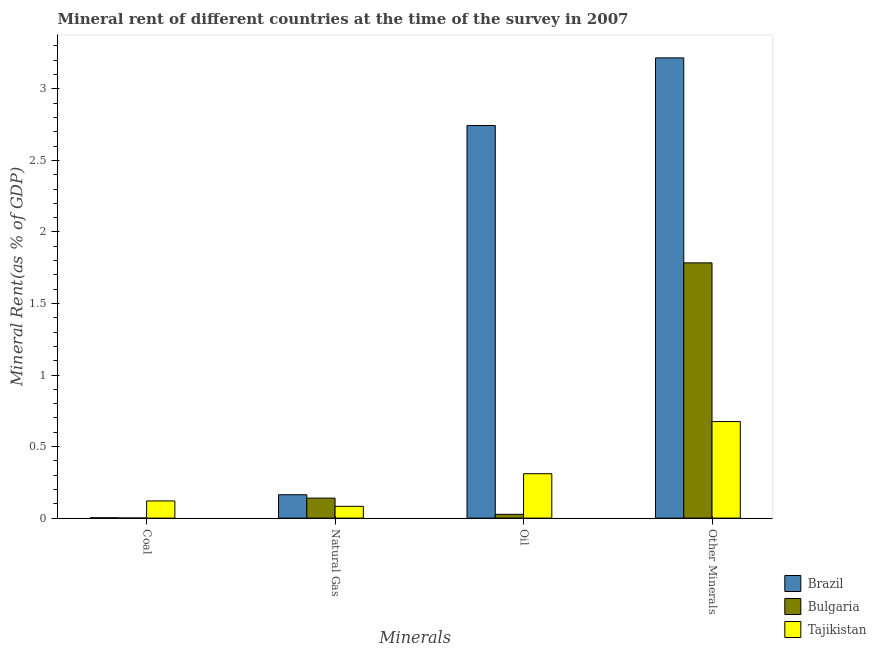How many different coloured bars are there?
Make the answer very short. 3. Are the number of bars per tick equal to the number of legend labels?
Your answer should be very brief. Yes. Are the number of bars on each tick of the X-axis equal?
Your answer should be compact. Yes. How many bars are there on the 1st tick from the left?
Provide a short and direct response. 3. How many bars are there on the 4th tick from the right?
Ensure brevity in your answer.  3. What is the label of the 3rd group of bars from the left?
Offer a terse response. Oil. What is the oil rent in Bulgaria?
Provide a short and direct response. 0.03. Across all countries, what is the maximum  rent of other minerals?
Ensure brevity in your answer.  3.22. Across all countries, what is the minimum oil rent?
Keep it short and to the point. 0.03. What is the total coal rent in the graph?
Make the answer very short. 0.12. What is the difference between the oil rent in Tajikistan and that in Bulgaria?
Provide a short and direct response. 0.28. What is the difference between the coal rent in Bulgaria and the  rent of other minerals in Brazil?
Provide a succinct answer. -3.22. What is the average  rent of other minerals per country?
Your answer should be very brief. 1.89. What is the difference between the natural gas rent and  rent of other minerals in Brazil?
Give a very brief answer. -3.05. In how many countries, is the oil rent greater than 0.1 %?
Provide a succinct answer. 2. What is the ratio of the natural gas rent in Tajikistan to that in Brazil?
Keep it short and to the point. 0.5. What is the difference between the highest and the second highest natural gas rent?
Give a very brief answer. 0.02. What is the difference between the highest and the lowest  rent of other minerals?
Provide a succinct answer. 2.54. In how many countries, is the natural gas rent greater than the average natural gas rent taken over all countries?
Give a very brief answer. 2. Is the sum of the natural gas rent in Bulgaria and Tajikistan greater than the maximum oil rent across all countries?
Provide a succinct answer. No. Is it the case that in every country, the sum of the oil rent and natural gas rent is greater than the sum of coal rent and  rent of other minerals?
Give a very brief answer. No. What does the 1st bar from the left in Oil represents?
Your response must be concise. Brazil. What does the 3rd bar from the right in Oil represents?
Ensure brevity in your answer.  Brazil. How many bars are there?
Your answer should be compact. 12. What is the difference between two consecutive major ticks on the Y-axis?
Give a very brief answer. 0.5. What is the title of the graph?
Offer a terse response. Mineral rent of different countries at the time of the survey in 2007. Does "Latvia" appear as one of the legend labels in the graph?
Give a very brief answer. No. What is the label or title of the X-axis?
Your answer should be very brief. Minerals. What is the label or title of the Y-axis?
Provide a short and direct response. Mineral Rent(as % of GDP). What is the Mineral Rent(as % of GDP) in Brazil in Coal?
Offer a very short reply. 0. What is the Mineral Rent(as % of GDP) of Bulgaria in Coal?
Keep it short and to the point. 0. What is the Mineral Rent(as % of GDP) in Tajikistan in Coal?
Offer a terse response. 0.12. What is the Mineral Rent(as % of GDP) in Brazil in Natural Gas?
Ensure brevity in your answer.  0.16. What is the Mineral Rent(as % of GDP) of Bulgaria in Natural Gas?
Provide a short and direct response. 0.14. What is the Mineral Rent(as % of GDP) in Tajikistan in Natural Gas?
Your response must be concise. 0.08. What is the Mineral Rent(as % of GDP) of Brazil in Oil?
Your answer should be compact. 2.74. What is the Mineral Rent(as % of GDP) of Bulgaria in Oil?
Provide a short and direct response. 0.03. What is the Mineral Rent(as % of GDP) of Tajikistan in Oil?
Offer a very short reply. 0.31. What is the Mineral Rent(as % of GDP) of Brazil in Other Minerals?
Your answer should be compact. 3.22. What is the Mineral Rent(as % of GDP) of Bulgaria in Other Minerals?
Make the answer very short. 1.78. What is the Mineral Rent(as % of GDP) of Tajikistan in Other Minerals?
Make the answer very short. 0.67. Across all Minerals, what is the maximum Mineral Rent(as % of GDP) of Brazil?
Provide a succinct answer. 3.22. Across all Minerals, what is the maximum Mineral Rent(as % of GDP) in Bulgaria?
Your answer should be compact. 1.78. Across all Minerals, what is the maximum Mineral Rent(as % of GDP) of Tajikistan?
Your answer should be very brief. 0.67. Across all Minerals, what is the minimum Mineral Rent(as % of GDP) of Brazil?
Give a very brief answer. 0. Across all Minerals, what is the minimum Mineral Rent(as % of GDP) of Bulgaria?
Offer a terse response. 0. Across all Minerals, what is the minimum Mineral Rent(as % of GDP) in Tajikistan?
Your answer should be compact. 0.08. What is the total Mineral Rent(as % of GDP) of Brazil in the graph?
Ensure brevity in your answer.  6.13. What is the total Mineral Rent(as % of GDP) in Bulgaria in the graph?
Ensure brevity in your answer.  1.95. What is the total Mineral Rent(as % of GDP) of Tajikistan in the graph?
Your answer should be compact. 1.19. What is the difference between the Mineral Rent(as % of GDP) in Brazil in Coal and that in Natural Gas?
Offer a very short reply. -0.16. What is the difference between the Mineral Rent(as % of GDP) of Bulgaria in Coal and that in Natural Gas?
Provide a succinct answer. -0.14. What is the difference between the Mineral Rent(as % of GDP) of Tajikistan in Coal and that in Natural Gas?
Offer a terse response. 0.04. What is the difference between the Mineral Rent(as % of GDP) in Brazil in Coal and that in Oil?
Ensure brevity in your answer.  -2.74. What is the difference between the Mineral Rent(as % of GDP) in Bulgaria in Coal and that in Oil?
Your answer should be compact. -0.03. What is the difference between the Mineral Rent(as % of GDP) of Tajikistan in Coal and that in Oil?
Your answer should be very brief. -0.19. What is the difference between the Mineral Rent(as % of GDP) of Brazil in Coal and that in Other Minerals?
Ensure brevity in your answer.  -3.21. What is the difference between the Mineral Rent(as % of GDP) of Bulgaria in Coal and that in Other Minerals?
Your answer should be compact. -1.78. What is the difference between the Mineral Rent(as % of GDP) of Tajikistan in Coal and that in Other Minerals?
Ensure brevity in your answer.  -0.55. What is the difference between the Mineral Rent(as % of GDP) of Brazil in Natural Gas and that in Oil?
Offer a terse response. -2.58. What is the difference between the Mineral Rent(as % of GDP) of Bulgaria in Natural Gas and that in Oil?
Make the answer very short. 0.11. What is the difference between the Mineral Rent(as % of GDP) of Tajikistan in Natural Gas and that in Oil?
Your response must be concise. -0.23. What is the difference between the Mineral Rent(as % of GDP) of Brazil in Natural Gas and that in Other Minerals?
Your answer should be very brief. -3.05. What is the difference between the Mineral Rent(as % of GDP) of Bulgaria in Natural Gas and that in Other Minerals?
Make the answer very short. -1.64. What is the difference between the Mineral Rent(as % of GDP) in Tajikistan in Natural Gas and that in Other Minerals?
Offer a terse response. -0.59. What is the difference between the Mineral Rent(as % of GDP) of Brazil in Oil and that in Other Minerals?
Provide a succinct answer. -0.47. What is the difference between the Mineral Rent(as % of GDP) in Bulgaria in Oil and that in Other Minerals?
Your answer should be compact. -1.76. What is the difference between the Mineral Rent(as % of GDP) of Tajikistan in Oil and that in Other Minerals?
Offer a very short reply. -0.36. What is the difference between the Mineral Rent(as % of GDP) in Brazil in Coal and the Mineral Rent(as % of GDP) in Bulgaria in Natural Gas?
Provide a short and direct response. -0.14. What is the difference between the Mineral Rent(as % of GDP) in Brazil in Coal and the Mineral Rent(as % of GDP) in Tajikistan in Natural Gas?
Your response must be concise. -0.08. What is the difference between the Mineral Rent(as % of GDP) in Bulgaria in Coal and the Mineral Rent(as % of GDP) in Tajikistan in Natural Gas?
Your answer should be very brief. -0.08. What is the difference between the Mineral Rent(as % of GDP) of Brazil in Coal and the Mineral Rent(as % of GDP) of Bulgaria in Oil?
Your answer should be compact. -0.02. What is the difference between the Mineral Rent(as % of GDP) of Brazil in Coal and the Mineral Rent(as % of GDP) of Tajikistan in Oil?
Ensure brevity in your answer.  -0.31. What is the difference between the Mineral Rent(as % of GDP) of Bulgaria in Coal and the Mineral Rent(as % of GDP) of Tajikistan in Oil?
Your answer should be compact. -0.31. What is the difference between the Mineral Rent(as % of GDP) in Brazil in Coal and the Mineral Rent(as % of GDP) in Bulgaria in Other Minerals?
Make the answer very short. -1.78. What is the difference between the Mineral Rent(as % of GDP) in Brazil in Coal and the Mineral Rent(as % of GDP) in Tajikistan in Other Minerals?
Keep it short and to the point. -0.67. What is the difference between the Mineral Rent(as % of GDP) of Bulgaria in Coal and the Mineral Rent(as % of GDP) of Tajikistan in Other Minerals?
Offer a terse response. -0.67. What is the difference between the Mineral Rent(as % of GDP) of Brazil in Natural Gas and the Mineral Rent(as % of GDP) of Bulgaria in Oil?
Your answer should be very brief. 0.14. What is the difference between the Mineral Rent(as % of GDP) of Brazil in Natural Gas and the Mineral Rent(as % of GDP) of Tajikistan in Oil?
Provide a succinct answer. -0.15. What is the difference between the Mineral Rent(as % of GDP) in Bulgaria in Natural Gas and the Mineral Rent(as % of GDP) in Tajikistan in Oil?
Make the answer very short. -0.17. What is the difference between the Mineral Rent(as % of GDP) of Brazil in Natural Gas and the Mineral Rent(as % of GDP) of Bulgaria in Other Minerals?
Make the answer very short. -1.62. What is the difference between the Mineral Rent(as % of GDP) in Brazil in Natural Gas and the Mineral Rent(as % of GDP) in Tajikistan in Other Minerals?
Your answer should be compact. -0.51. What is the difference between the Mineral Rent(as % of GDP) in Bulgaria in Natural Gas and the Mineral Rent(as % of GDP) in Tajikistan in Other Minerals?
Make the answer very short. -0.54. What is the difference between the Mineral Rent(as % of GDP) in Brazil in Oil and the Mineral Rent(as % of GDP) in Bulgaria in Other Minerals?
Your response must be concise. 0.96. What is the difference between the Mineral Rent(as % of GDP) of Brazil in Oil and the Mineral Rent(as % of GDP) of Tajikistan in Other Minerals?
Your answer should be compact. 2.07. What is the difference between the Mineral Rent(as % of GDP) in Bulgaria in Oil and the Mineral Rent(as % of GDP) in Tajikistan in Other Minerals?
Your answer should be compact. -0.65. What is the average Mineral Rent(as % of GDP) of Brazil per Minerals?
Offer a very short reply. 1.53. What is the average Mineral Rent(as % of GDP) in Bulgaria per Minerals?
Provide a short and direct response. 0.49. What is the average Mineral Rent(as % of GDP) of Tajikistan per Minerals?
Your answer should be compact. 0.3. What is the difference between the Mineral Rent(as % of GDP) in Brazil and Mineral Rent(as % of GDP) in Bulgaria in Coal?
Make the answer very short. 0. What is the difference between the Mineral Rent(as % of GDP) of Brazil and Mineral Rent(as % of GDP) of Tajikistan in Coal?
Your response must be concise. -0.12. What is the difference between the Mineral Rent(as % of GDP) in Bulgaria and Mineral Rent(as % of GDP) in Tajikistan in Coal?
Keep it short and to the point. -0.12. What is the difference between the Mineral Rent(as % of GDP) in Brazil and Mineral Rent(as % of GDP) in Bulgaria in Natural Gas?
Ensure brevity in your answer.  0.02. What is the difference between the Mineral Rent(as % of GDP) of Brazil and Mineral Rent(as % of GDP) of Tajikistan in Natural Gas?
Ensure brevity in your answer.  0.08. What is the difference between the Mineral Rent(as % of GDP) of Bulgaria and Mineral Rent(as % of GDP) of Tajikistan in Natural Gas?
Offer a terse response. 0.06. What is the difference between the Mineral Rent(as % of GDP) of Brazil and Mineral Rent(as % of GDP) of Bulgaria in Oil?
Provide a short and direct response. 2.72. What is the difference between the Mineral Rent(as % of GDP) of Brazil and Mineral Rent(as % of GDP) of Tajikistan in Oil?
Offer a terse response. 2.43. What is the difference between the Mineral Rent(as % of GDP) of Bulgaria and Mineral Rent(as % of GDP) of Tajikistan in Oil?
Make the answer very short. -0.28. What is the difference between the Mineral Rent(as % of GDP) in Brazil and Mineral Rent(as % of GDP) in Bulgaria in Other Minerals?
Your answer should be very brief. 1.43. What is the difference between the Mineral Rent(as % of GDP) in Brazil and Mineral Rent(as % of GDP) in Tajikistan in Other Minerals?
Make the answer very short. 2.54. What is the difference between the Mineral Rent(as % of GDP) in Bulgaria and Mineral Rent(as % of GDP) in Tajikistan in Other Minerals?
Provide a succinct answer. 1.11. What is the ratio of the Mineral Rent(as % of GDP) in Brazil in Coal to that in Natural Gas?
Offer a very short reply. 0.01. What is the ratio of the Mineral Rent(as % of GDP) in Bulgaria in Coal to that in Natural Gas?
Keep it short and to the point. 0.01. What is the ratio of the Mineral Rent(as % of GDP) of Tajikistan in Coal to that in Natural Gas?
Ensure brevity in your answer.  1.46. What is the ratio of the Mineral Rent(as % of GDP) of Brazil in Coal to that in Oil?
Give a very brief answer. 0. What is the ratio of the Mineral Rent(as % of GDP) in Bulgaria in Coal to that in Oil?
Ensure brevity in your answer.  0.03. What is the ratio of the Mineral Rent(as % of GDP) of Tajikistan in Coal to that in Oil?
Your answer should be very brief. 0.39. What is the ratio of the Mineral Rent(as % of GDP) in Brazil in Coal to that in Other Minerals?
Provide a short and direct response. 0. What is the ratio of the Mineral Rent(as % of GDP) in Tajikistan in Coal to that in Other Minerals?
Offer a very short reply. 0.18. What is the ratio of the Mineral Rent(as % of GDP) in Brazil in Natural Gas to that in Oil?
Offer a terse response. 0.06. What is the ratio of the Mineral Rent(as % of GDP) of Bulgaria in Natural Gas to that in Oil?
Your answer should be very brief. 5.26. What is the ratio of the Mineral Rent(as % of GDP) in Tajikistan in Natural Gas to that in Oil?
Offer a terse response. 0.27. What is the ratio of the Mineral Rent(as % of GDP) of Brazil in Natural Gas to that in Other Minerals?
Provide a short and direct response. 0.05. What is the ratio of the Mineral Rent(as % of GDP) of Bulgaria in Natural Gas to that in Other Minerals?
Your response must be concise. 0.08. What is the ratio of the Mineral Rent(as % of GDP) in Tajikistan in Natural Gas to that in Other Minerals?
Your answer should be very brief. 0.12. What is the ratio of the Mineral Rent(as % of GDP) in Brazil in Oil to that in Other Minerals?
Your response must be concise. 0.85. What is the ratio of the Mineral Rent(as % of GDP) of Bulgaria in Oil to that in Other Minerals?
Give a very brief answer. 0.01. What is the ratio of the Mineral Rent(as % of GDP) in Tajikistan in Oil to that in Other Minerals?
Your answer should be compact. 0.46. What is the difference between the highest and the second highest Mineral Rent(as % of GDP) in Brazil?
Offer a terse response. 0.47. What is the difference between the highest and the second highest Mineral Rent(as % of GDP) in Bulgaria?
Ensure brevity in your answer.  1.64. What is the difference between the highest and the second highest Mineral Rent(as % of GDP) in Tajikistan?
Your answer should be compact. 0.36. What is the difference between the highest and the lowest Mineral Rent(as % of GDP) in Brazil?
Keep it short and to the point. 3.21. What is the difference between the highest and the lowest Mineral Rent(as % of GDP) of Bulgaria?
Provide a short and direct response. 1.78. What is the difference between the highest and the lowest Mineral Rent(as % of GDP) of Tajikistan?
Make the answer very short. 0.59. 